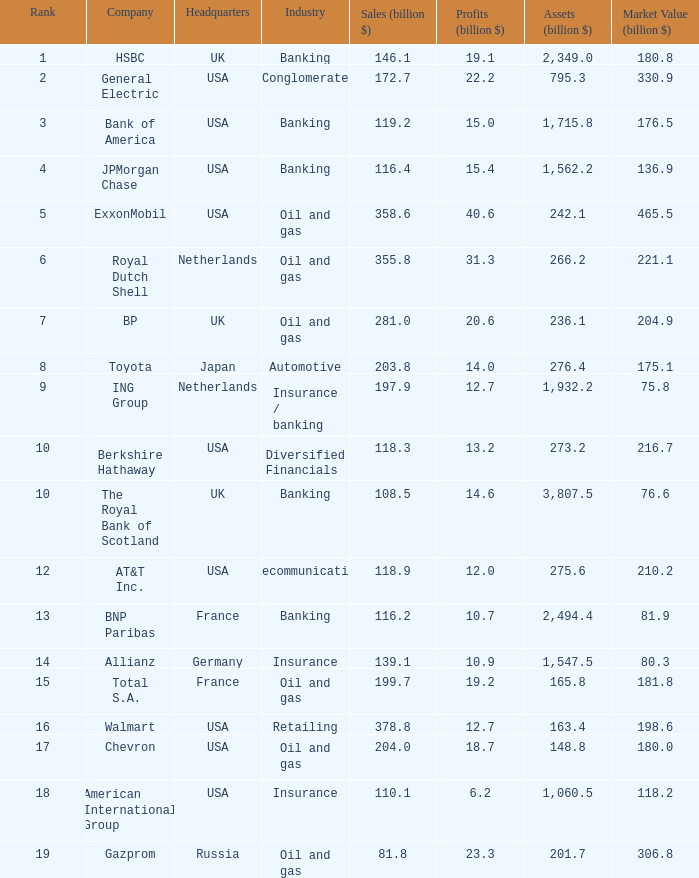What is the maximum rank attained by a corporation possessing 1,715.8 billion in assets? 3.0. 